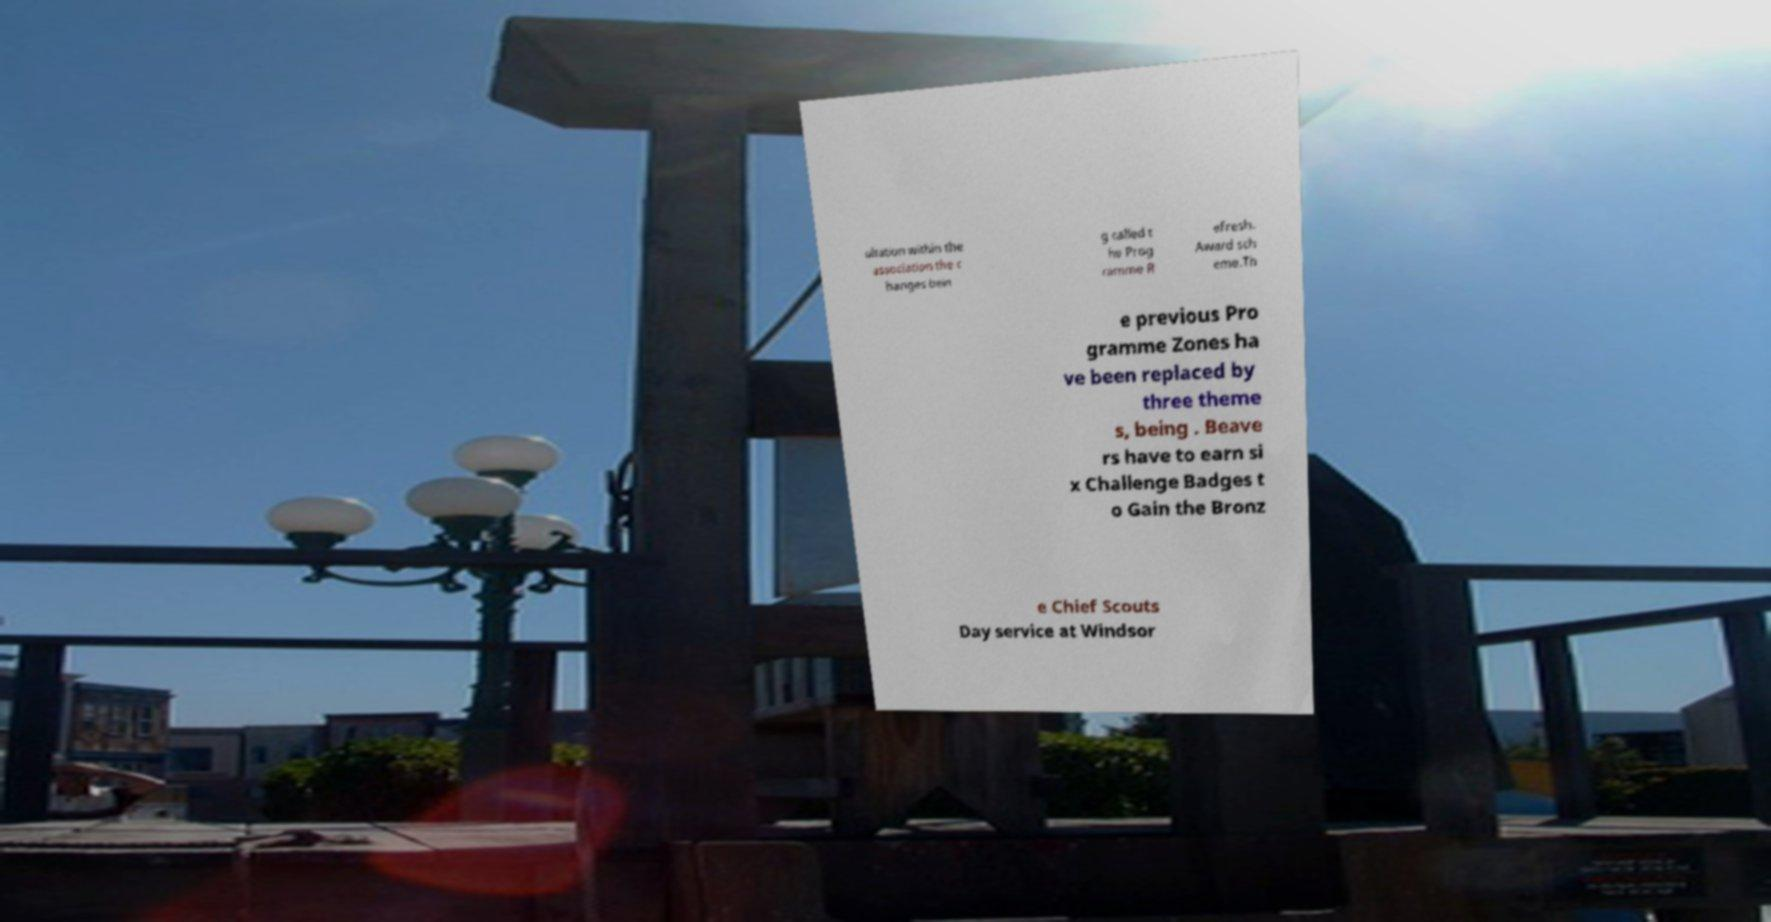Please identify and transcribe the text found in this image. ultation within the association the c hanges bein g called t he Prog ramme R efresh. Award sch eme.Th e previous Pro gramme Zones ha ve been replaced by three theme s, being . Beave rs have to earn si x Challenge Badges t o Gain the Bronz e Chief Scouts Day service at Windsor 